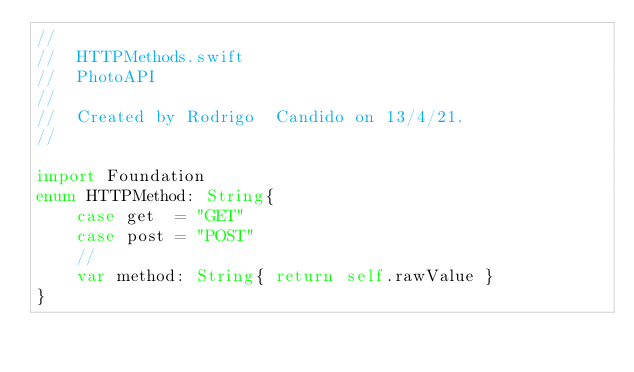<code> <loc_0><loc_0><loc_500><loc_500><_Swift_>//
//  HTTPMethods.swift
//  PhotoAPI
//
//  Created by Rodrigo  Candido on 13/4/21.
//

import Foundation
enum HTTPMethod: String{
    case get  = "GET"
    case post = "POST"
    //
    var method: String{ return self.rawValue }
}
</code> 